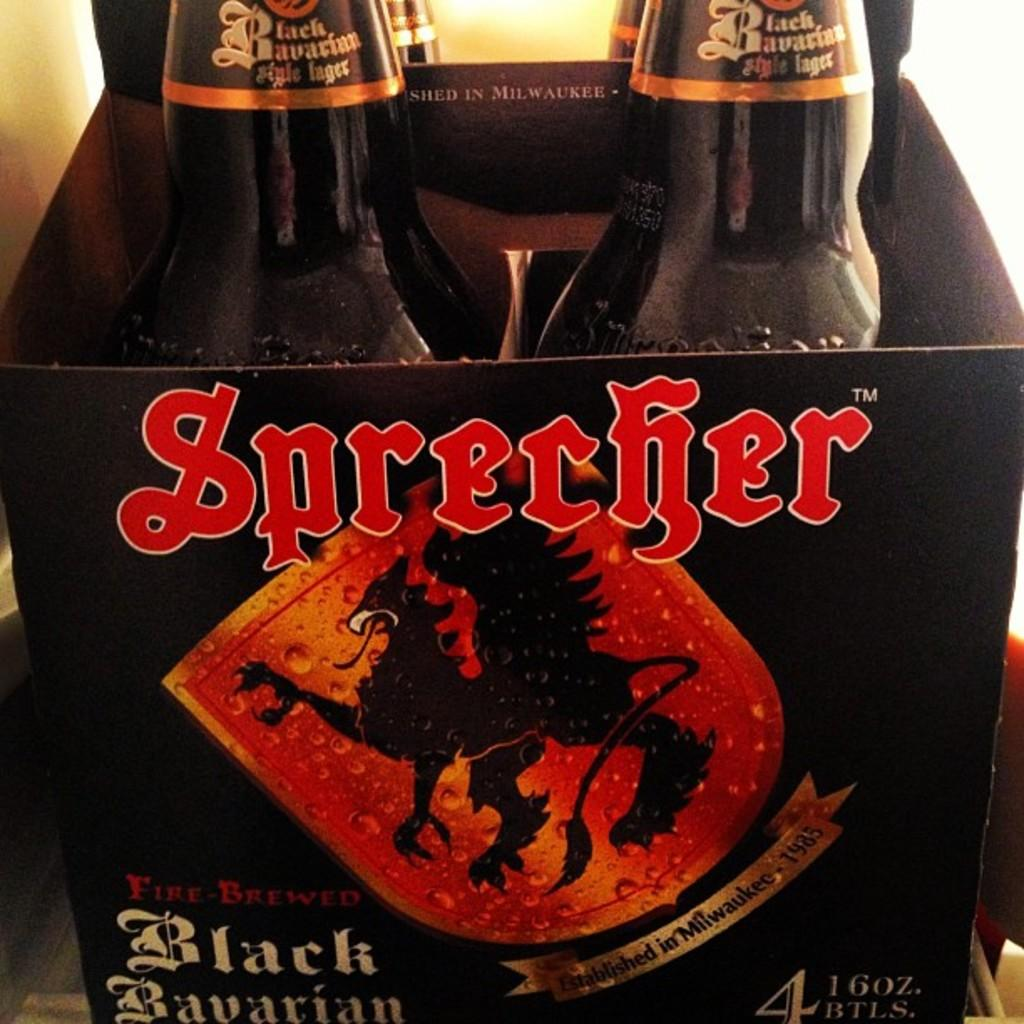<image>
Summarize the visual content of the image. A pack of Sprecher beer has a shield design on the box. 